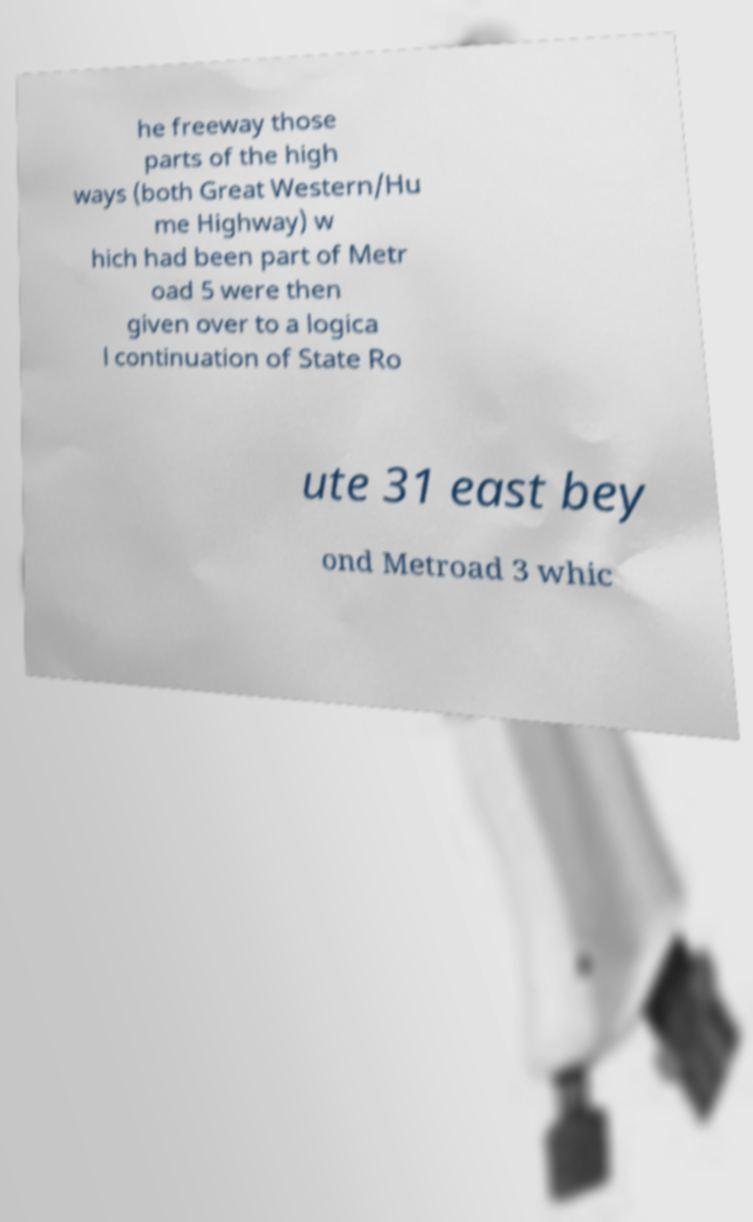Please read and relay the text visible in this image. What does it say? he freeway those parts of the high ways (both Great Western/Hu me Highway) w hich had been part of Metr oad 5 were then given over to a logica l continuation of State Ro ute 31 east bey ond Metroad 3 whic 